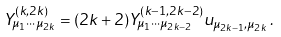<formula> <loc_0><loc_0><loc_500><loc_500>Y ^ { ( k , 2 k ) } _ { \mu _ { 1 } \cdots \mu _ { 2 k } } = ( 2 k + 2 ) Y ^ { ( k - 1 , 2 k - 2 ) } _ { \mu _ { 1 } \cdots \mu _ { 2 k - 2 } } u _ { \mu _ { 2 k - 1 } , \mu _ { 2 k } } \, .</formula> 